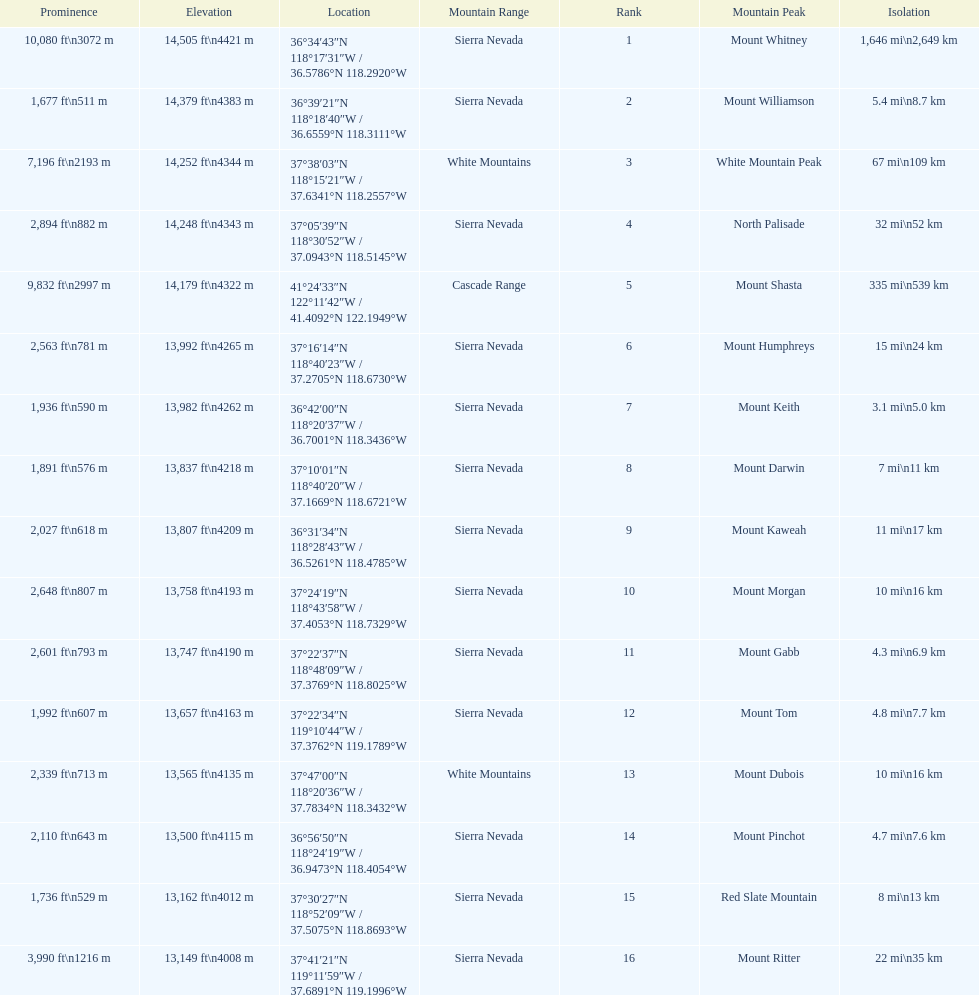Is the peak of mount keith above or below the peak of north palisade? Below. 